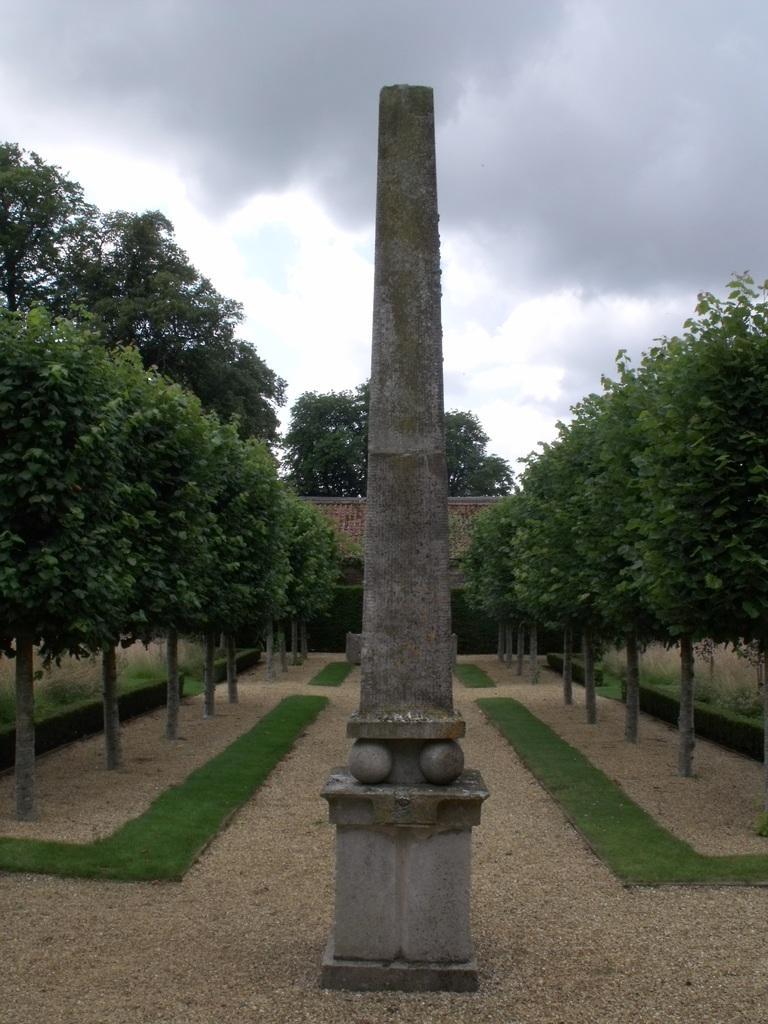How would you summarize this image in a sentence or two? In the center of the image we can see a house, roof, pillar. In the background of the image we can see the trees, grass. At the bottom of the image we can see the ground. At the top of the image we can see the clouds are present in the sky. 